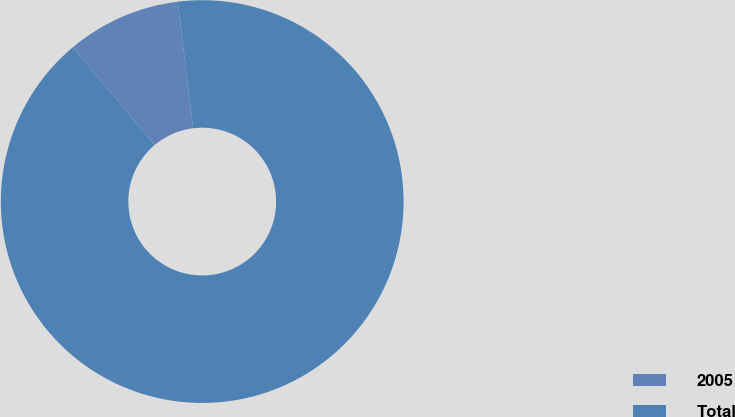Convert chart. <chart><loc_0><loc_0><loc_500><loc_500><pie_chart><fcel>2005<fcel>Total<nl><fcel>9.16%<fcel>90.84%<nl></chart> 